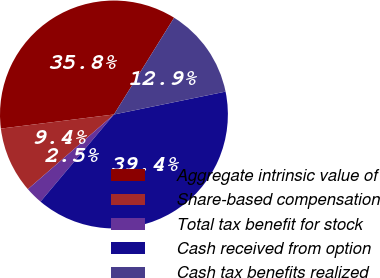Convert chart. <chart><loc_0><loc_0><loc_500><loc_500><pie_chart><fcel>Aggregate intrinsic value of<fcel>Share-based compensation<fcel>Total tax benefit for stock<fcel>Cash received from option<fcel>Cash tax benefits realized<nl><fcel>35.83%<fcel>9.4%<fcel>2.48%<fcel>39.36%<fcel>12.93%<nl></chart> 